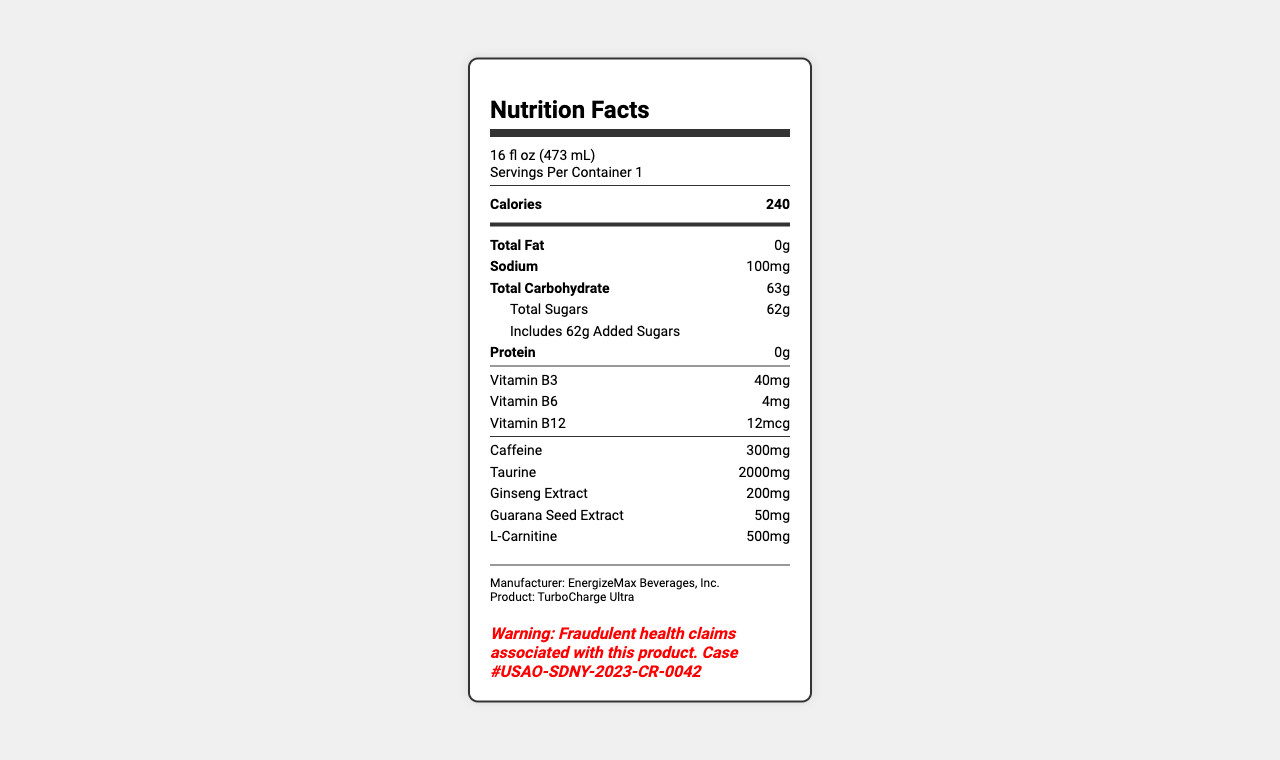What is the serving size for TurboCharge Ultra? The serving size is clearly stated near the top of the document.
Answer: 16 fl oz (473 mL) How many calories does one serving of TurboCharge Ultra contain? The number of calories is listed prominently in the bold section under the title "Calories."
Answer: 240 How much total carbohydrate is in TurboCharge Ultra? Total carbohydrate content is listed in the section after the "Total Fat" and "Sodium" sections.
Answer: 63g What is the sodium content in TurboCharge Ultra? The sodium content is listed under the "Total Fat" section.
Answer: 100mg What fraudulent claim is associated with TurboCharge Ultra? This information is provided in the data under the term "fraudulent_claim."
Answer: Clinically proven to reverse aging and prevent cancer Who is the manufacturer of TurboCharge Ultra? The manufacturer's name can be found in the extra information section at the bottom of the document.
Answer: EnergizeMax Beverages, Inc. Who is the defendant in the case? The defendant's name is specified in the data.
Answer: Dr. Helena Voss, CEO of EnergizeMax Beverages, Inc. Which agency investigated the case against TurboCharge Ultra? The investigating agency is mentioned in the data under "investigating_agency."
Answer: FDA Office of Criminal Investigations How many grams of sugar are in TurboCharge Ultra? The total sugar content is specified under the "Total Carbohydrate" section.
Answer: 62g How much caffeine is in TurboCharge Ultra? A. 100mg B. 200mg C. 300mg D. 400mg The caffeine content is listed in the "nutrient" section towards the bottom of the document.
Answer: C. 300mg Does TurboCharge Ultra contain any protein? The document indicates that the protein content is 0g.
Answer: No Is TurboCharge Ultra's vitamin B6 content higher than usual daily requirements for adults? 4mg of vitamin B6 is a high amount compared to the typical daily requirement of 1.3-1.7mg for adults.
Answer: Yes Describe the nutrition facts label for TurboCharge Ultra. The label shows all relevant nutritional details, manufacturer information, and highlights the fraudulent claims associated with the product and the legal warning.
Answer: The document provides detailed nutritional information for TurboCharge Ultra, including serving size, calories, and the amounts of various nutrients and ingredients. Additionally, it contains a warning about fraudulent health claims and legal information related to the case. What is the source of the primary evidence in the case against TurboCharge Ultra? The document does not provide details on where the primary evidence was obtained, only that it is falsified clinical trial data submitted to the FDA.
Answer: Cannot be determined 